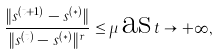<formula> <loc_0><loc_0><loc_500><loc_500>\frac { \| s ^ { ( t + 1 ) } - s ^ { ( * ) } \| } { \| s ^ { ( t ) } - s ^ { ( * ) } \| ^ { r } } \leq \mu \, \text {as} \, t \rightarrow + \infty ,</formula> 